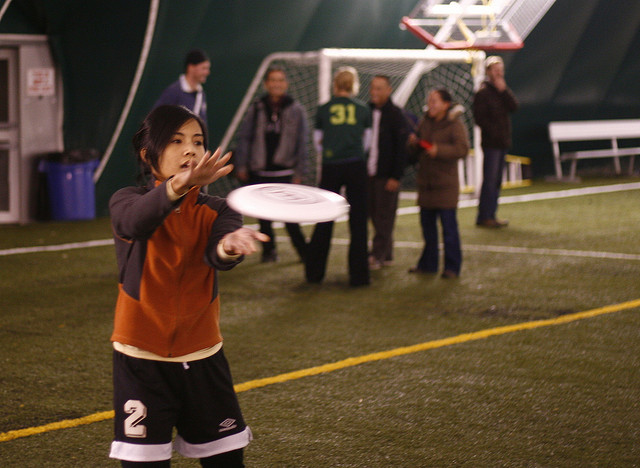Identify and read out the text in this image. 2 31 